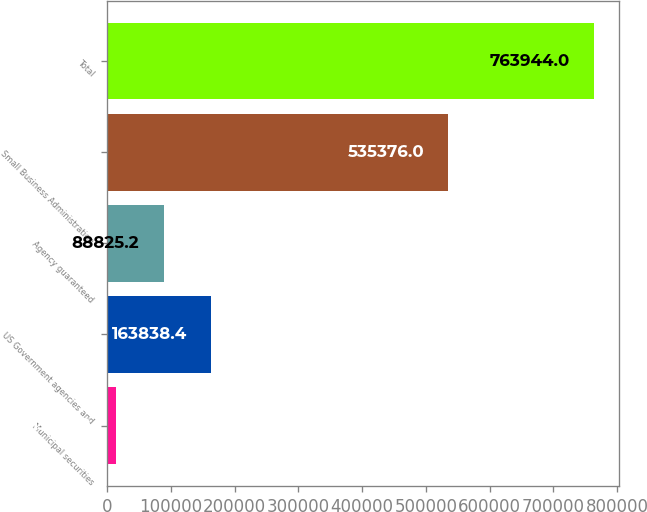<chart> <loc_0><loc_0><loc_500><loc_500><bar_chart><fcel>Municipal securities<fcel>US Government agencies and<fcel>Agency guaranteed<fcel>Small Business Administration<fcel>Total<nl><fcel>13812<fcel>163838<fcel>88825.2<fcel>535376<fcel>763944<nl></chart> 